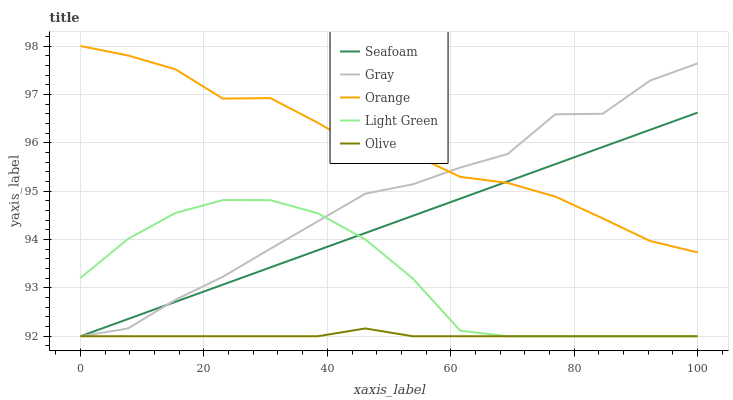Does Olive have the minimum area under the curve?
Answer yes or no. Yes. Does Orange have the maximum area under the curve?
Answer yes or no. Yes. Does Gray have the minimum area under the curve?
Answer yes or no. No. Does Gray have the maximum area under the curve?
Answer yes or no. No. Is Seafoam the smoothest?
Answer yes or no. Yes. Is Gray the roughest?
Answer yes or no. Yes. Is Gray the smoothest?
Answer yes or no. No. Is Seafoam the roughest?
Answer yes or no. No. Does Orange have the highest value?
Answer yes or no. Yes. Does Gray have the highest value?
Answer yes or no. No. Is Olive less than Orange?
Answer yes or no. Yes. Is Orange greater than Olive?
Answer yes or no. Yes. Does Gray intersect Light Green?
Answer yes or no. Yes. Is Gray less than Light Green?
Answer yes or no. No. Is Gray greater than Light Green?
Answer yes or no. No. Does Olive intersect Orange?
Answer yes or no. No. 